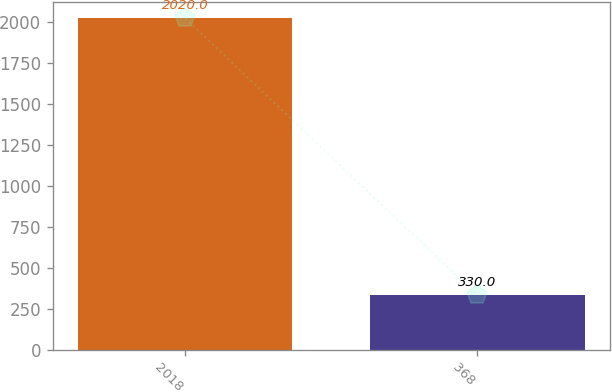Convert chart. <chart><loc_0><loc_0><loc_500><loc_500><bar_chart><fcel>2018<fcel>368<nl><fcel>2020<fcel>330<nl></chart> 